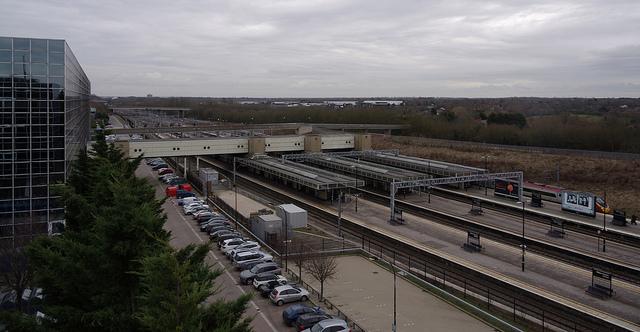Sunny or overcast?
Concise answer only. Overcast. Is there more than one platform shown?
Write a very short answer. Yes. Is it cloudy?
Keep it brief. Yes. What type of road are the cars on?
Short answer required. Highway. Is the car made of metal?
Be succinct. Yes. Is there lots of greenery?
Concise answer only. No. Is there a pedestrian walkway?
Quick response, please. Yes. What color is the vehicle that is on the left side of the truck?
Short answer required. White. Is the train traveling through an urban area?
Short answer required. Yes. Is this a parking lot?
Quick response, please. Yes. What is cast?
Give a very brief answer. Sky. 